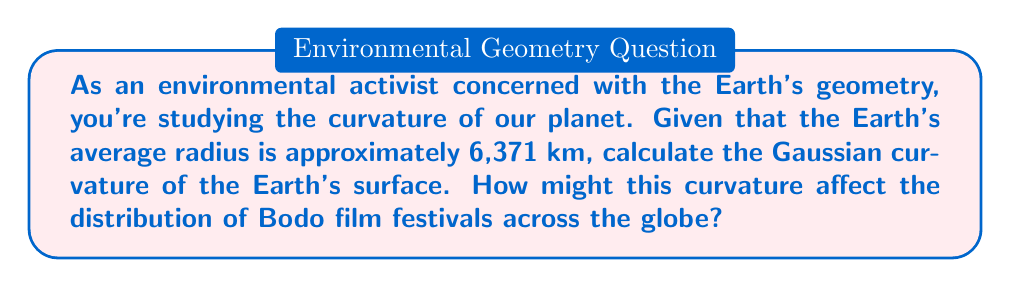Can you solve this math problem? Let's approach this step-by-step:

1) The Gaussian curvature ($K$) of a sphere is constant and given by the formula:

   $$K = \frac{1}{R^2}$$

   where $R$ is the radius of the sphere.

2) We're given that the Earth's average radius is 6,371 km. Let's substitute this into our formula:

   $$K = \frac{1}{(6,371 \text{ km})^2}$$

3) Now, let's calculate:

   $$K = \frac{1}{40,589,641 \text{ km}^2} \approx 2.46 \times 10^{-14} \text{ km}^{-2}$$

4) To convert to SI units (m^-2):

   $$K \approx 2.46 \times 10^{-14} \text{ km}^{-2} \times (1000 \text{ m/km})^2 = 2.46 \times 10^{-8} \text{ m}^{-2}$$

5) Regarding Bodo film festivals:
   The curvature affects long-distance travel and event planning. For festivals spanning large areas, the curvature would need to be considered for accurate distance calculations and time zone management.

[asy]
import geometry;

size(200);
pair O=(0,0);
real R=5;
draw(circle(O,R));
draw(O--R*dir(45),Arrow);
label("R",R*dir(45)/2,NE);
label("Earth's surface",O,fontsize(10));
[/asy]
Answer: $2.46 \times 10^{-8} \text{ m}^{-2}$ 